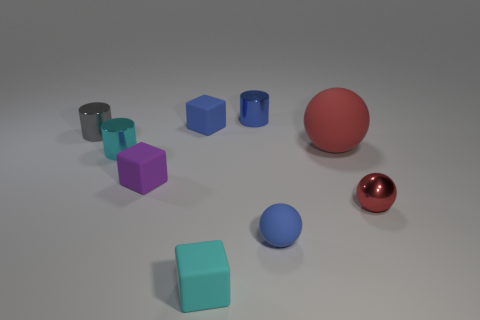Is there a pattern or specific arrangement to the objects in the image? The objects appear to be deliberately placed; however, they don't seem to follow a rigid pattern. They are arranged with a degree of randomness yet with adequate separation between them, which might suggest an intent to display each object clearly without any overlapping, possibly for a comparative purpose or display. 